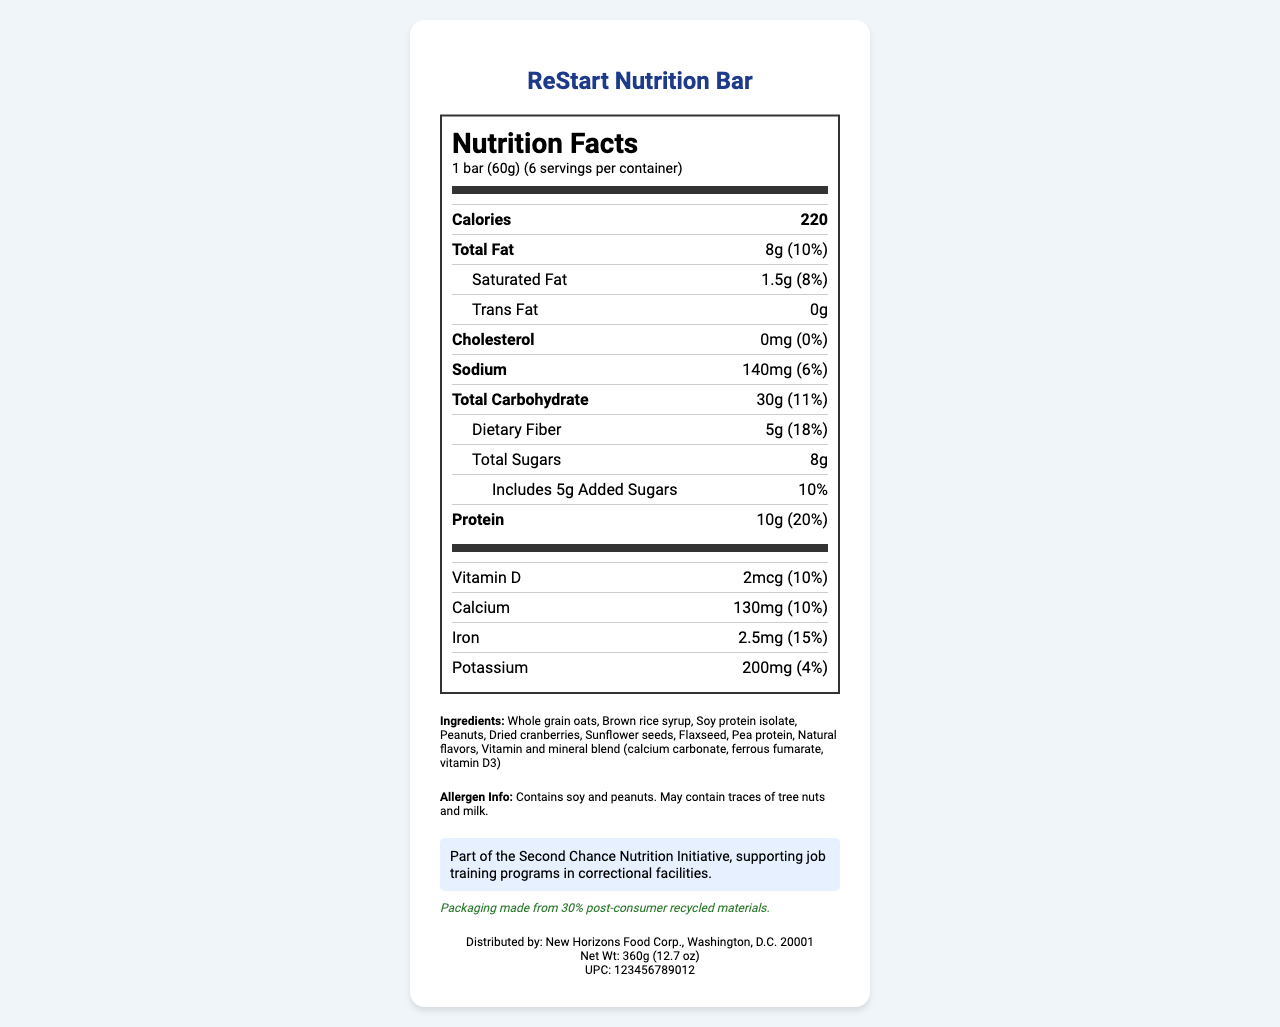what is the serving size of the ReStart Nutrition Bar? The serving size information is clearly listed on the document as "1 bar (60g)".
Answer: 1 bar (60g) how many calories are in one serving? The document states that there are 220 calories per serving.
Answer: 220 calories what are the total carbohydrates in a serving of the ReStart Nutrition Bar? The total carbohydrates per serving are listed as 30g.
Answer: 30g how much protein is in one ReStart Nutrition Bar? The protein content per serving is given as 10g.
Answer: 10g what is the amount of dietary fiber in one bar? The dietary fiber amount per serving is indicated as 5g.
Answer: 5g what percentage of the daily value for calcium does one serving of the ReStart Nutrition Bar provide? A. 5% B. 10% C. 15% D. 20% The document shows that one serving provides 10% of the daily value for calcium.
Answer: B. 10% which ingredient is NOT listed in the ReStart Nutrition Bar? A. Whole grain oats B. Almonds C. Dried cranberries D. Pea protein The list of ingredients does not include almonds.
Answer: B. Almonds does the ReStart Nutrition Bar contain any cholesterol? The document states that the cholesterol amount is 0mg, which means it does not contain any cholesterol.
Answer: No is the packaging of the ReStart Nutrition Bar sustainable? The sustainability note mentions that the packaging is made from 30% post-consumer recycled materials.
Answer: Yes summarize the key points about the ReStart Nutrition Bar. This summary includes all main points about the nutrition, ingredients, allergen info, sustainability, and the rehabilitation program associated with the ReStart Nutrition Bar.
Answer: The ReStart Nutrition Bar is a nutritious food product part of the Second Chance Nutrition Initiative, which supports job training programs in correctional facilities. Each serving (1 bar, 60g) contains 220 calories, 8g of total fat, 30g of carbohydrates, 10g of protein, and various vitamins and minerals. It contains ingredients like whole grain oats, soy protein isolate, and dried cranberries and is allergen-friendly for those with soy or peanut allergies. The product is distributed by New Horizons Food Corp. and features sustainable packaging. what is the weight of one container of ReStart Nutrition Bars? The net weight of one container is listed as 360g.
Answer: 360g how many servings are in one container of ReStart Nutrition Bar? The document clearly states that there are 6 servings per container.
Answer: 6 servings what is the percent daily value of vitamin D provided in one serving? The percent daily value for vitamin D is given as 10%.
Answer: 10% does the document mention the price of the ReStart Nutrition Bar? The document does not contain any information regarding the price of the ReStart Nutrition Bar.
Answer: Not enough information 